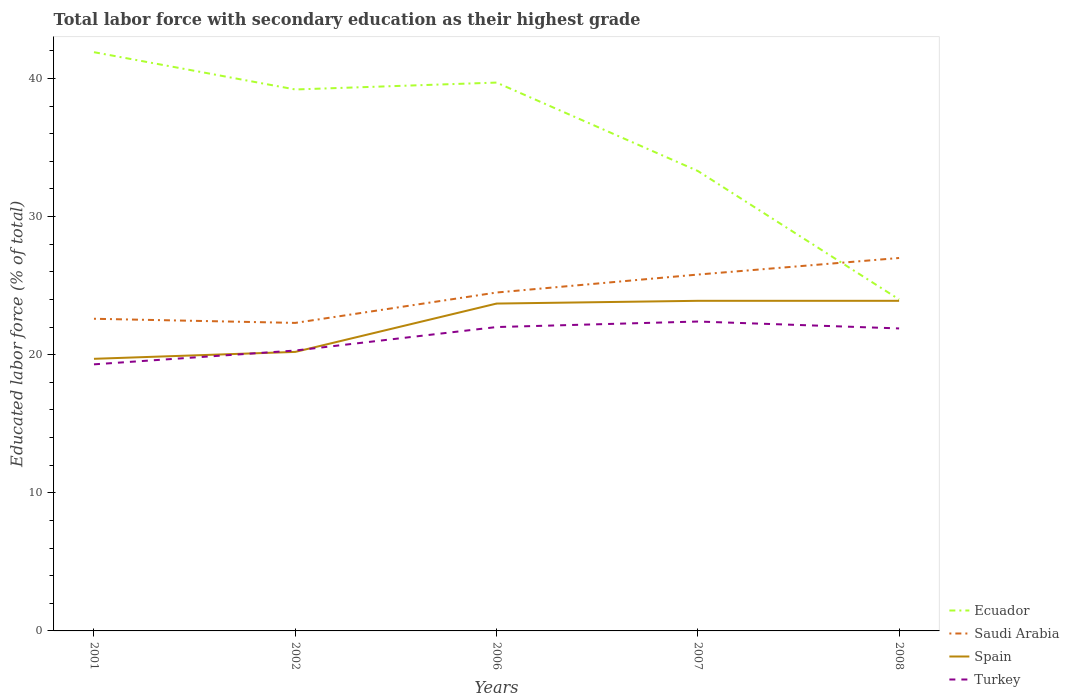How many different coloured lines are there?
Provide a succinct answer. 4. Does the line corresponding to Ecuador intersect with the line corresponding to Turkey?
Ensure brevity in your answer.  No. Is the number of lines equal to the number of legend labels?
Your answer should be compact. Yes. Across all years, what is the maximum percentage of total labor force with primary education in Spain?
Offer a very short reply. 19.7. In which year was the percentage of total labor force with primary education in Spain maximum?
Give a very brief answer. 2001. What is the total percentage of total labor force with primary education in Ecuador in the graph?
Your response must be concise. 6.4. What is the difference between the highest and the second highest percentage of total labor force with primary education in Ecuador?
Keep it short and to the point. 17.9. How many lines are there?
Offer a very short reply. 4. What is the difference between two consecutive major ticks on the Y-axis?
Make the answer very short. 10. How many legend labels are there?
Keep it short and to the point. 4. How are the legend labels stacked?
Keep it short and to the point. Vertical. What is the title of the graph?
Offer a terse response. Total labor force with secondary education as their highest grade. Does "Micronesia" appear as one of the legend labels in the graph?
Your answer should be very brief. No. What is the label or title of the X-axis?
Offer a terse response. Years. What is the label or title of the Y-axis?
Make the answer very short. Educated labor force (% of total). What is the Educated labor force (% of total) of Ecuador in 2001?
Offer a terse response. 41.9. What is the Educated labor force (% of total) of Saudi Arabia in 2001?
Provide a short and direct response. 22.6. What is the Educated labor force (% of total) of Spain in 2001?
Make the answer very short. 19.7. What is the Educated labor force (% of total) of Turkey in 2001?
Keep it short and to the point. 19.3. What is the Educated labor force (% of total) in Ecuador in 2002?
Provide a succinct answer. 39.2. What is the Educated labor force (% of total) in Saudi Arabia in 2002?
Offer a very short reply. 22.3. What is the Educated labor force (% of total) in Spain in 2002?
Your answer should be very brief. 20.2. What is the Educated labor force (% of total) of Turkey in 2002?
Offer a terse response. 20.3. What is the Educated labor force (% of total) of Ecuador in 2006?
Your answer should be compact. 39.7. What is the Educated labor force (% of total) of Spain in 2006?
Ensure brevity in your answer.  23.7. What is the Educated labor force (% of total) of Ecuador in 2007?
Your answer should be compact. 33.3. What is the Educated labor force (% of total) in Saudi Arabia in 2007?
Your response must be concise. 25.8. What is the Educated labor force (% of total) in Spain in 2007?
Make the answer very short. 23.9. What is the Educated labor force (% of total) of Turkey in 2007?
Offer a terse response. 22.4. What is the Educated labor force (% of total) of Ecuador in 2008?
Provide a short and direct response. 24. What is the Educated labor force (% of total) of Spain in 2008?
Your answer should be very brief. 23.9. What is the Educated labor force (% of total) of Turkey in 2008?
Your response must be concise. 21.9. Across all years, what is the maximum Educated labor force (% of total) in Ecuador?
Provide a short and direct response. 41.9. Across all years, what is the maximum Educated labor force (% of total) in Spain?
Make the answer very short. 23.9. Across all years, what is the maximum Educated labor force (% of total) in Turkey?
Your response must be concise. 22.4. Across all years, what is the minimum Educated labor force (% of total) of Saudi Arabia?
Provide a short and direct response. 22.3. Across all years, what is the minimum Educated labor force (% of total) in Spain?
Provide a short and direct response. 19.7. Across all years, what is the minimum Educated labor force (% of total) in Turkey?
Offer a terse response. 19.3. What is the total Educated labor force (% of total) in Ecuador in the graph?
Your response must be concise. 178.1. What is the total Educated labor force (% of total) in Saudi Arabia in the graph?
Provide a short and direct response. 122.2. What is the total Educated labor force (% of total) in Spain in the graph?
Your response must be concise. 111.4. What is the total Educated labor force (% of total) in Turkey in the graph?
Provide a succinct answer. 105.9. What is the difference between the Educated labor force (% of total) of Saudi Arabia in 2001 and that in 2002?
Provide a succinct answer. 0.3. What is the difference between the Educated labor force (% of total) of Spain in 2001 and that in 2002?
Offer a very short reply. -0.5. What is the difference between the Educated labor force (% of total) of Turkey in 2001 and that in 2002?
Offer a terse response. -1. What is the difference between the Educated labor force (% of total) in Ecuador in 2001 and that in 2007?
Provide a succinct answer. 8.6. What is the difference between the Educated labor force (% of total) of Turkey in 2001 and that in 2007?
Make the answer very short. -3.1. What is the difference between the Educated labor force (% of total) of Saudi Arabia in 2001 and that in 2008?
Offer a terse response. -4.4. What is the difference between the Educated labor force (% of total) of Turkey in 2001 and that in 2008?
Your response must be concise. -2.6. What is the difference between the Educated labor force (% of total) in Ecuador in 2002 and that in 2006?
Your answer should be very brief. -0.5. What is the difference between the Educated labor force (% of total) in Saudi Arabia in 2002 and that in 2006?
Offer a terse response. -2.2. What is the difference between the Educated labor force (% of total) in Turkey in 2002 and that in 2006?
Your answer should be compact. -1.7. What is the difference between the Educated labor force (% of total) of Saudi Arabia in 2002 and that in 2007?
Provide a short and direct response. -3.5. What is the difference between the Educated labor force (% of total) of Spain in 2002 and that in 2007?
Give a very brief answer. -3.7. What is the difference between the Educated labor force (% of total) of Ecuador in 2002 and that in 2008?
Provide a short and direct response. 15.2. What is the difference between the Educated labor force (% of total) of Spain in 2002 and that in 2008?
Provide a short and direct response. -3.7. What is the difference between the Educated labor force (% of total) in Turkey in 2002 and that in 2008?
Keep it short and to the point. -1.6. What is the difference between the Educated labor force (% of total) in Spain in 2006 and that in 2007?
Offer a very short reply. -0.2. What is the difference between the Educated labor force (% of total) of Turkey in 2006 and that in 2007?
Offer a very short reply. -0.4. What is the difference between the Educated labor force (% of total) of Saudi Arabia in 2006 and that in 2008?
Ensure brevity in your answer.  -2.5. What is the difference between the Educated labor force (% of total) of Spain in 2006 and that in 2008?
Provide a short and direct response. -0.2. What is the difference between the Educated labor force (% of total) in Turkey in 2006 and that in 2008?
Keep it short and to the point. 0.1. What is the difference between the Educated labor force (% of total) in Ecuador in 2007 and that in 2008?
Provide a short and direct response. 9.3. What is the difference between the Educated labor force (% of total) in Spain in 2007 and that in 2008?
Give a very brief answer. 0. What is the difference between the Educated labor force (% of total) of Ecuador in 2001 and the Educated labor force (% of total) of Saudi Arabia in 2002?
Provide a short and direct response. 19.6. What is the difference between the Educated labor force (% of total) of Ecuador in 2001 and the Educated labor force (% of total) of Spain in 2002?
Make the answer very short. 21.7. What is the difference between the Educated labor force (% of total) in Ecuador in 2001 and the Educated labor force (% of total) in Turkey in 2002?
Make the answer very short. 21.6. What is the difference between the Educated labor force (% of total) in Saudi Arabia in 2001 and the Educated labor force (% of total) in Spain in 2002?
Your answer should be compact. 2.4. What is the difference between the Educated labor force (% of total) in Saudi Arabia in 2001 and the Educated labor force (% of total) in Spain in 2006?
Keep it short and to the point. -1.1. What is the difference between the Educated labor force (% of total) of Saudi Arabia in 2001 and the Educated labor force (% of total) of Turkey in 2006?
Offer a terse response. 0.6. What is the difference between the Educated labor force (% of total) in Ecuador in 2001 and the Educated labor force (% of total) in Spain in 2007?
Provide a short and direct response. 18. What is the difference between the Educated labor force (% of total) of Ecuador in 2001 and the Educated labor force (% of total) of Turkey in 2007?
Provide a short and direct response. 19.5. What is the difference between the Educated labor force (% of total) of Ecuador in 2001 and the Educated labor force (% of total) of Saudi Arabia in 2008?
Offer a terse response. 14.9. What is the difference between the Educated labor force (% of total) in Ecuador in 2001 and the Educated labor force (% of total) in Spain in 2008?
Offer a very short reply. 18. What is the difference between the Educated labor force (% of total) in Ecuador in 2002 and the Educated labor force (% of total) in Saudi Arabia in 2006?
Offer a terse response. 14.7. What is the difference between the Educated labor force (% of total) in Ecuador in 2002 and the Educated labor force (% of total) in Turkey in 2006?
Make the answer very short. 17.2. What is the difference between the Educated labor force (% of total) of Saudi Arabia in 2002 and the Educated labor force (% of total) of Spain in 2006?
Your response must be concise. -1.4. What is the difference between the Educated labor force (% of total) in Ecuador in 2002 and the Educated labor force (% of total) in Saudi Arabia in 2007?
Your answer should be very brief. 13.4. What is the difference between the Educated labor force (% of total) in Ecuador in 2002 and the Educated labor force (% of total) in Spain in 2007?
Ensure brevity in your answer.  15.3. What is the difference between the Educated labor force (% of total) of Saudi Arabia in 2002 and the Educated labor force (% of total) of Turkey in 2007?
Your response must be concise. -0.1. What is the difference between the Educated labor force (% of total) in Spain in 2002 and the Educated labor force (% of total) in Turkey in 2007?
Make the answer very short. -2.2. What is the difference between the Educated labor force (% of total) of Saudi Arabia in 2002 and the Educated labor force (% of total) of Spain in 2008?
Your answer should be very brief. -1.6. What is the difference between the Educated labor force (% of total) of Saudi Arabia in 2002 and the Educated labor force (% of total) of Turkey in 2008?
Your answer should be very brief. 0.4. What is the difference between the Educated labor force (% of total) of Spain in 2002 and the Educated labor force (% of total) of Turkey in 2008?
Offer a terse response. -1.7. What is the difference between the Educated labor force (% of total) of Ecuador in 2006 and the Educated labor force (% of total) of Spain in 2007?
Your response must be concise. 15.8. What is the difference between the Educated labor force (% of total) of Saudi Arabia in 2006 and the Educated labor force (% of total) of Spain in 2007?
Provide a succinct answer. 0.6. What is the difference between the Educated labor force (% of total) of Ecuador in 2006 and the Educated labor force (% of total) of Spain in 2008?
Your response must be concise. 15.8. What is the difference between the Educated labor force (% of total) of Ecuador in 2006 and the Educated labor force (% of total) of Turkey in 2008?
Offer a very short reply. 17.8. What is the difference between the Educated labor force (% of total) in Saudi Arabia in 2006 and the Educated labor force (% of total) in Spain in 2008?
Your answer should be very brief. 0.6. What is the difference between the Educated labor force (% of total) in Saudi Arabia in 2006 and the Educated labor force (% of total) in Turkey in 2008?
Your answer should be very brief. 2.6. What is the difference between the Educated labor force (% of total) in Ecuador in 2007 and the Educated labor force (% of total) in Saudi Arabia in 2008?
Provide a short and direct response. 6.3. What is the average Educated labor force (% of total) of Ecuador per year?
Ensure brevity in your answer.  35.62. What is the average Educated labor force (% of total) of Saudi Arabia per year?
Your answer should be very brief. 24.44. What is the average Educated labor force (% of total) of Spain per year?
Offer a terse response. 22.28. What is the average Educated labor force (% of total) of Turkey per year?
Offer a very short reply. 21.18. In the year 2001, what is the difference between the Educated labor force (% of total) of Ecuador and Educated labor force (% of total) of Saudi Arabia?
Ensure brevity in your answer.  19.3. In the year 2001, what is the difference between the Educated labor force (% of total) in Ecuador and Educated labor force (% of total) in Turkey?
Provide a succinct answer. 22.6. In the year 2001, what is the difference between the Educated labor force (% of total) in Saudi Arabia and Educated labor force (% of total) in Turkey?
Provide a succinct answer. 3.3. In the year 2002, what is the difference between the Educated labor force (% of total) of Ecuador and Educated labor force (% of total) of Spain?
Make the answer very short. 19. In the year 2002, what is the difference between the Educated labor force (% of total) in Ecuador and Educated labor force (% of total) in Turkey?
Ensure brevity in your answer.  18.9. In the year 2002, what is the difference between the Educated labor force (% of total) of Saudi Arabia and Educated labor force (% of total) of Spain?
Keep it short and to the point. 2.1. In the year 2002, what is the difference between the Educated labor force (% of total) in Spain and Educated labor force (% of total) in Turkey?
Offer a terse response. -0.1. In the year 2006, what is the difference between the Educated labor force (% of total) of Ecuador and Educated labor force (% of total) of Saudi Arabia?
Offer a terse response. 15.2. In the year 2006, what is the difference between the Educated labor force (% of total) in Ecuador and Educated labor force (% of total) in Spain?
Make the answer very short. 16. In the year 2006, what is the difference between the Educated labor force (% of total) in Saudi Arabia and Educated labor force (% of total) in Turkey?
Offer a terse response. 2.5. In the year 2007, what is the difference between the Educated labor force (% of total) of Ecuador and Educated labor force (% of total) of Saudi Arabia?
Offer a very short reply. 7.5. In the year 2007, what is the difference between the Educated labor force (% of total) in Ecuador and Educated labor force (% of total) in Turkey?
Ensure brevity in your answer.  10.9. In the year 2007, what is the difference between the Educated labor force (% of total) of Saudi Arabia and Educated labor force (% of total) of Spain?
Provide a short and direct response. 1.9. In the year 2007, what is the difference between the Educated labor force (% of total) in Saudi Arabia and Educated labor force (% of total) in Turkey?
Make the answer very short. 3.4. In the year 2007, what is the difference between the Educated labor force (% of total) in Spain and Educated labor force (% of total) in Turkey?
Provide a succinct answer. 1.5. In the year 2008, what is the difference between the Educated labor force (% of total) in Ecuador and Educated labor force (% of total) in Spain?
Your response must be concise. 0.1. In the year 2008, what is the difference between the Educated labor force (% of total) in Saudi Arabia and Educated labor force (% of total) in Turkey?
Make the answer very short. 5.1. What is the ratio of the Educated labor force (% of total) in Ecuador in 2001 to that in 2002?
Ensure brevity in your answer.  1.07. What is the ratio of the Educated labor force (% of total) in Saudi Arabia in 2001 to that in 2002?
Make the answer very short. 1.01. What is the ratio of the Educated labor force (% of total) in Spain in 2001 to that in 2002?
Provide a short and direct response. 0.98. What is the ratio of the Educated labor force (% of total) in Turkey in 2001 to that in 2002?
Provide a short and direct response. 0.95. What is the ratio of the Educated labor force (% of total) in Ecuador in 2001 to that in 2006?
Ensure brevity in your answer.  1.06. What is the ratio of the Educated labor force (% of total) in Saudi Arabia in 2001 to that in 2006?
Offer a terse response. 0.92. What is the ratio of the Educated labor force (% of total) in Spain in 2001 to that in 2006?
Provide a short and direct response. 0.83. What is the ratio of the Educated labor force (% of total) in Turkey in 2001 to that in 2006?
Make the answer very short. 0.88. What is the ratio of the Educated labor force (% of total) in Ecuador in 2001 to that in 2007?
Make the answer very short. 1.26. What is the ratio of the Educated labor force (% of total) in Saudi Arabia in 2001 to that in 2007?
Keep it short and to the point. 0.88. What is the ratio of the Educated labor force (% of total) of Spain in 2001 to that in 2007?
Offer a terse response. 0.82. What is the ratio of the Educated labor force (% of total) in Turkey in 2001 to that in 2007?
Your response must be concise. 0.86. What is the ratio of the Educated labor force (% of total) of Ecuador in 2001 to that in 2008?
Your answer should be very brief. 1.75. What is the ratio of the Educated labor force (% of total) in Saudi Arabia in 2001 to that in 2008?
Offer a terse response. 0.84. What is the ratio of the Educated labor force (% of total) in Spain in 2001 to that in 2008?
Your answer should be compact. 0.82. What is the ratio of the Educated labor force (% of total) of Turkey in 2001 to that in 2008?
Make the answer very short. 0.88. What is the ratio of the Educated labor force (% of total) of Ecuador in 2002 to that in 2006?
Provide a short and direct response. 0.99. What is the ratio of the Educated labor force (% of total) of Saudi Arabia in 2002 to that in 2006?
Offer a very short reply. 0.91. What is the ratio of the Educated labor force (% of total) in Spain in 2002 to that in 2006?
Your response must be concise. 0.85. What is the ratio of the Educated labor force (% of total) of Turkey in 2002 to that in 2006?
Offer a very short reply. 0.92. What is the ratio of the Educated labor force (% of total) of Ecuador in 2002 to that in 2007?
Provide a short and direct response. 1.18. What is the ratio of the Educated labor force (% of total) in Saudi Arabia in 2002 to that in 2007?
Offer a terse response. 0.86. What is the ratio of the Educated labor force (% of total) of Spain in 2002 to that in 2007?
Offer a terse response. 0.85. What is the ratio of the Educated labor force (% of total) in Turkey in 2002 to that in 2007?
Offer a terse response. 0.91. What is the ratio of the Educated labor force (% of total) of Ecuador in 2002 to that in 2008?
Your answer should be very brief. 1.63. What is the ratio of the Educated labor force (% of total) of Saudi Arabia in 2002 to that in 2008?
Offer a terse response. 0.83. What is the ratio of the Educated labor force (% of total) in Spain in 2002 to that in 2008?
Provide a short and direct response. 0.85. What is the ratio of the Educated labor force (% of total) of Turkey in 2002 to that in 2008?
Give a very brief answer. 0.93. What is the ratio of the Educated labor force (% of total) in Ecuador in 2006 to that in 2007?
Provide a short and direct response. 1.19. What is the ratio of the Educated labor force (% of total) of Saudi Arabia in 2006 to that in 2007?
Offer a very short reply. 0.95. What is the ratio of the Educated labor force (% of total) of Spain in 2006 to that in 2007?
Provide a succinct answer. 0.99. What is the ratio of the Educated labor force (% of total) of Turkey in 2006 to that in 2007?
Your answer should be very brief. 0.98. What is the ratio of the Educated labor force (% of total) in Ecuador in 2006 to that in 2008?
Make the answer very short. 1.65. What is the ratio of the Educated labor force (% of total) in Saudi Arabia in 2006 to that in 2008?
Provide a succinct answer. 0.91. What is the ratio of the Educated labor force (% of total) of Ecuador in 2007 to that in 2008?
Your answer should be very brief. 1.39. What is the ratio of the Educated labor force (% of total) of Saudi Arabia in 2007 to that in 2008?
Offer a very short reply. 0.96. What is the ratio of the Educated labor force (% of total) in Spain in 2007 to that in 2008?
Keep it short and to the point. 1. What is the ratio of the Educated labor force (% of total) of Turkey in 2007 to that in 2008?
Your answer should be compact. 1.02. What is the difference between the highest and the second highest Educated labor force (% of total) of Spain?
Offer a very short reply. 0. What is the difference between the highest and the lowest Educated labor force (% of total) of Spain?
Ensure brevity in your answer.  4.2. What is the difference between the highest and the lowest Educated labor force (% of total) in Turkey?
Keep it short and to the point. 3.1. 